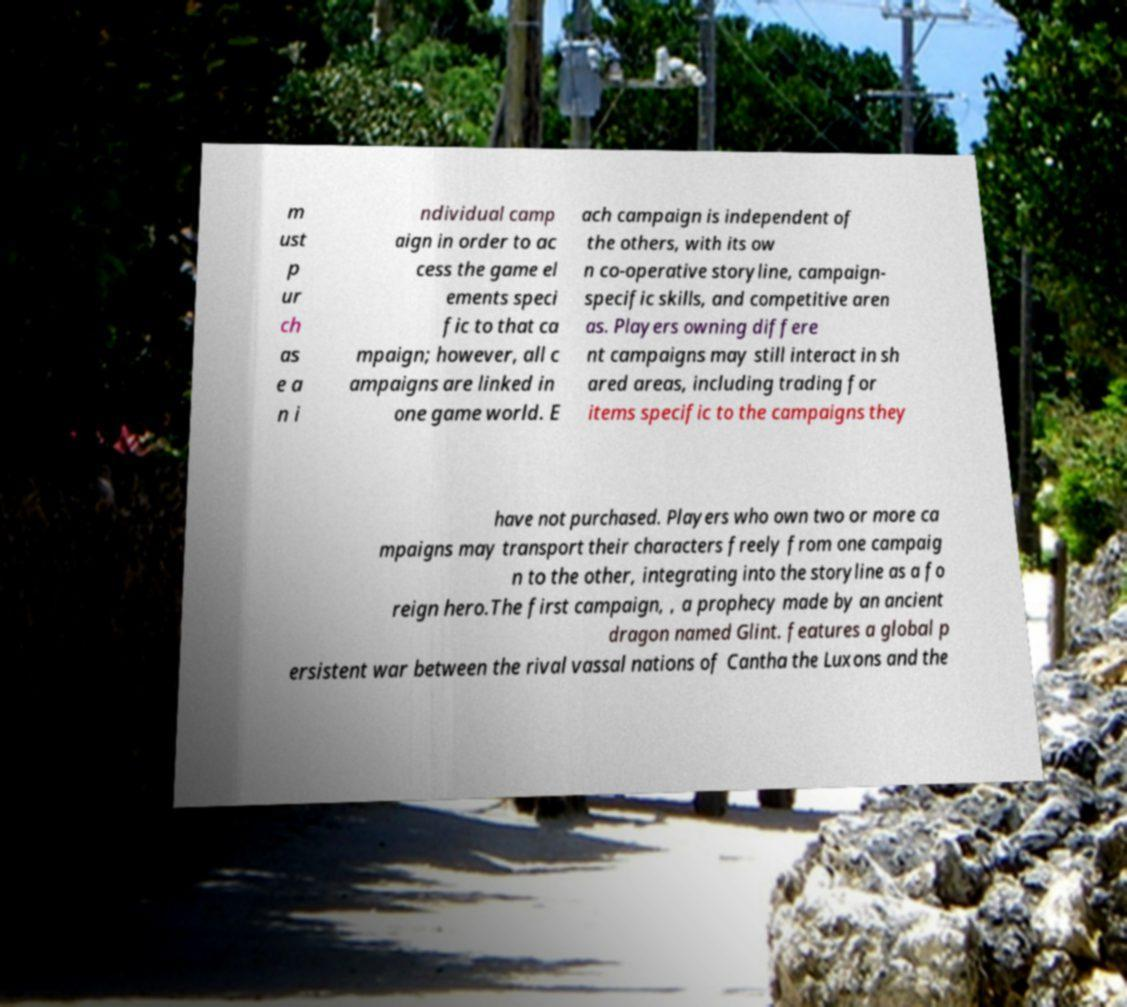What messages or text are displayed in this image? I need them in a readable, typed format. m ust p ur ch as e a n i ndividual camp aign in order to ac cess the game el ements speci fic to that ca mpaign; however, all c ampaigns are linked in one game world. E ach campaign is independent of the others, with its ow n co-operative storyline, campaign- specific skills, and competitive aren as. Players owning differe nt campaigns may still interact in sh ared areas, including trading for items specific to the campaigns they have not purchased. Players who own two or more ca mpaigns may transport their characters freely from one campaig n to the other, integrating into the storyline as a fo reign hero.The first campaign, , a prophecy made by an ancient dragon named Glint. features a global p ersistent war between the rival vassal nations of Cantha the Luxons and the 